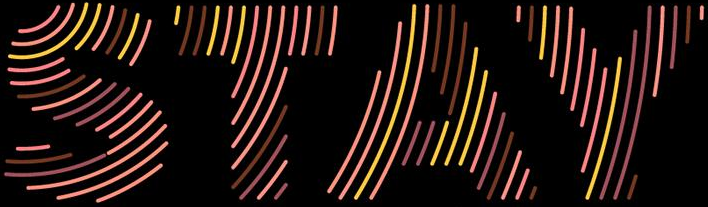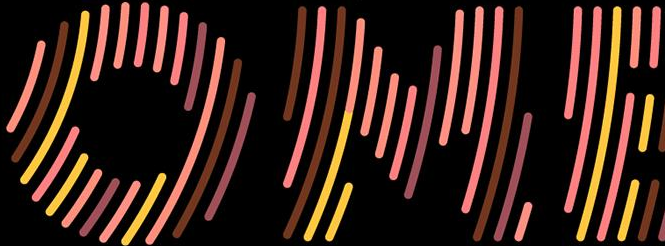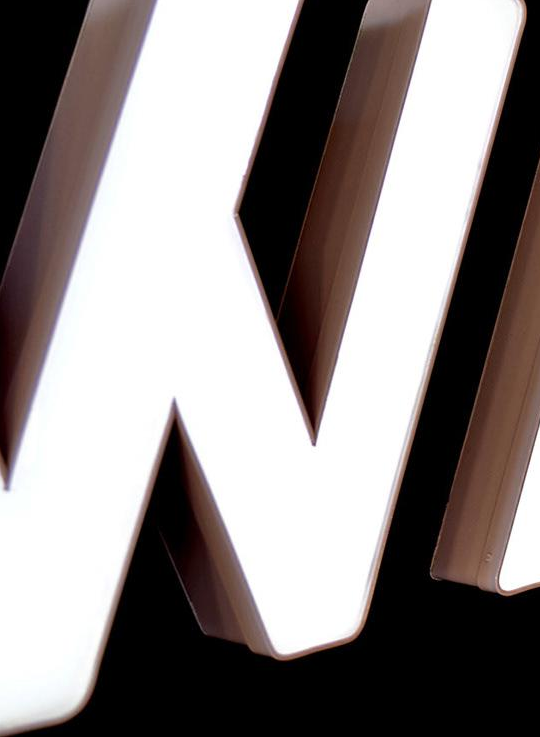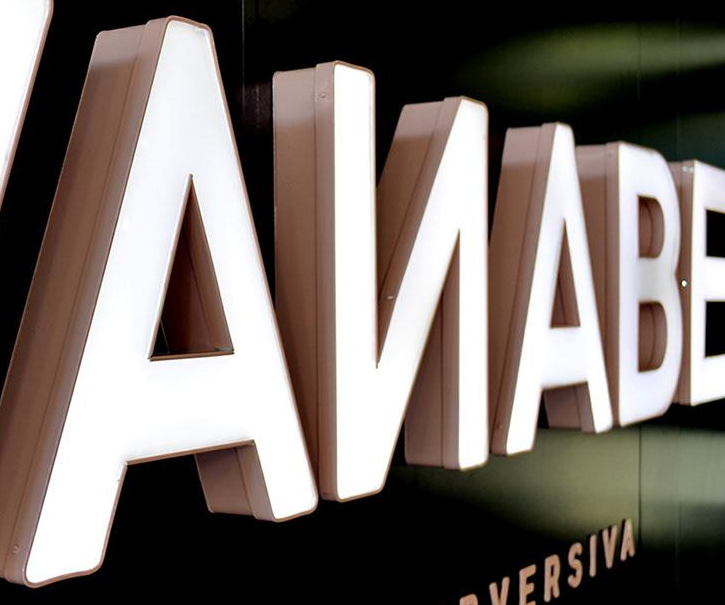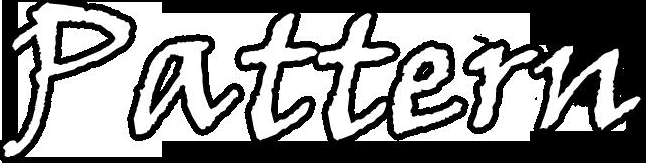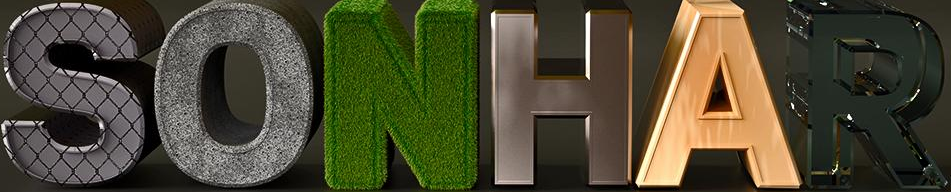Read the text from these images in sequence, separated by a semicolon. STAY; OME; #; AИABE; Pattern; SONHAR 